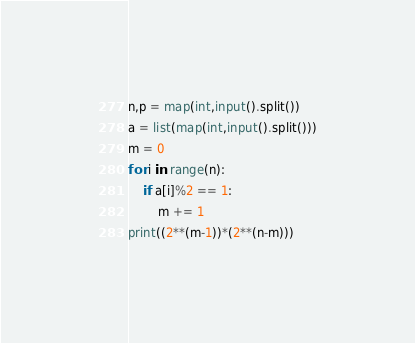<code> <loc_0><loc_0><loc_500><loc_500><_Python_>n,p = map(int,input().split())
a = list(map(int,input().split()))
m = 0
for i in range(n):
    if a[i]%2 == 1:
        m += 1
print((2**(m-1))*(2**(n-m)))
</code> 